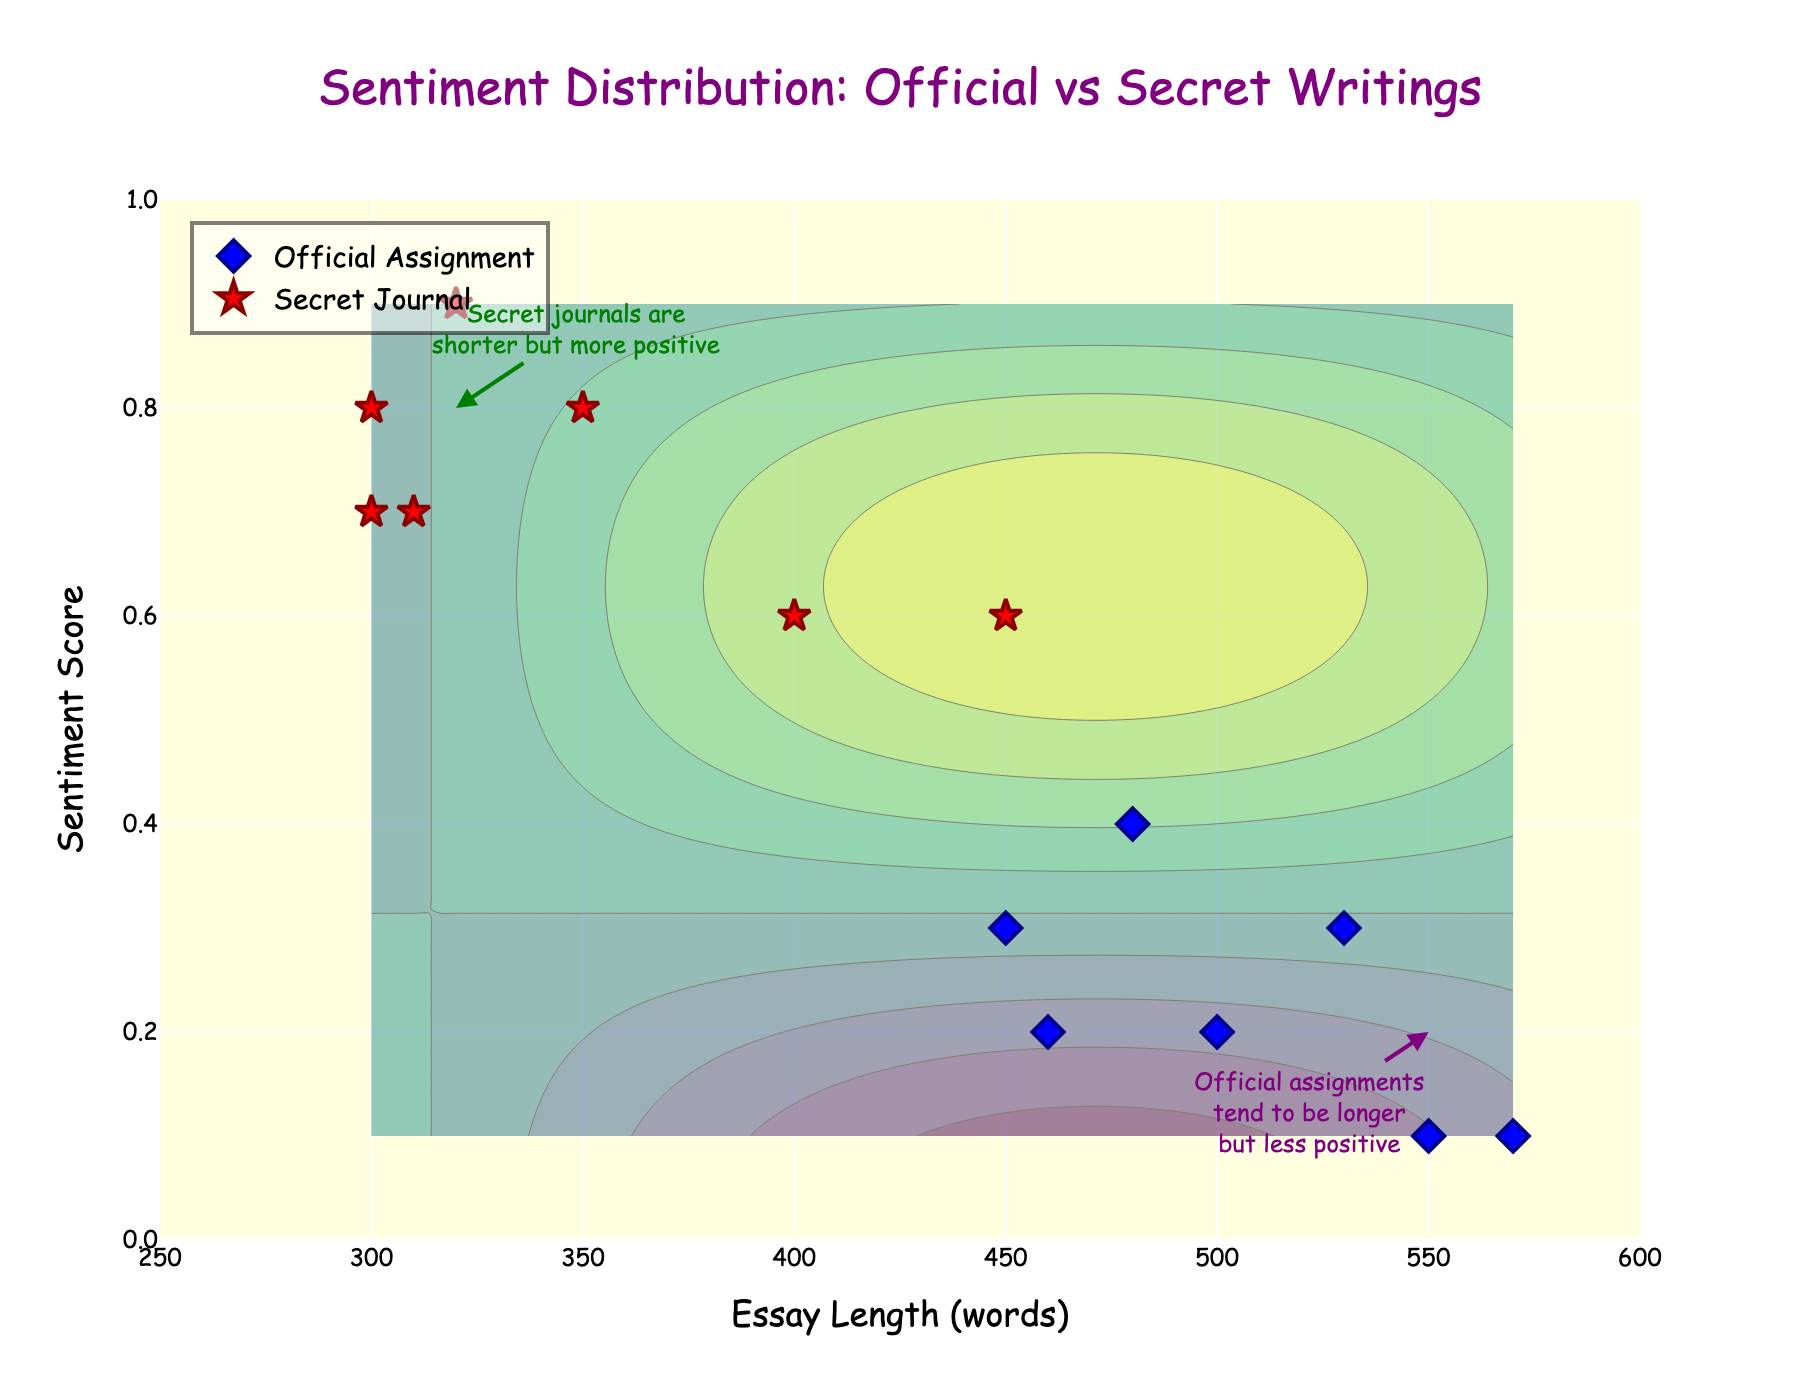What's the title of the plot? The title is located at the top of the plot and typically summarizes the main insight of the figure. In this plot, it's written in large, purple text to catch the viewer's attention.
Answer: Sentiment Distribution: Official vs Secret Writings What are the x-axis and y-axis titles? The titles for the axes are positioned along the axes themselves. The x-axis title describes what is being measured horizontally, while the y-axis title describes the vertical measurement. In this plot, they are easy to spot.
Answer: x-axis: Essay Length (words), y-axis: Sentiment Score How many data points represent Secret Journals? By looking at the markers labeled with the corresponding color for secret journals, we can count them. In this plot, red star markers represent secret journals.
Answer: 7 What's the average sentiment score for Official Assignments? Calculate the average sentiment score by first summing up all sentiment scores for official assignments (0.2 + 0.3 + 0.1 + 0.4 + 0.3 + 0.2 + 0.1), which equals 1.6. Then divide by the number of data points (7).
Answer: 0.229 In general, which type of essay tends to be longer? Compare the distributions along the x-axis for both types of essays. Official assignments are on average placed toward the right (longer lengths) while secret journals are more to the left (shorter lengths).
Answer: Official Assignments Which author has the highest sentiment score in their essay? By hovering over or reading the scatter plot markers, identify the highest point on the y-axis and check its label.
Answer: David Wilson (Secret Journal) What is the relationship between essay length and sentiment for Secret Journals? Look at the general trend of the red star markers. There appears to be a pattern in the plot indicating shorter essays generally have higher sentiment scores.
Answer: Shorter but more positive Compare the sentiment scores of Bob Smith's Official Assignment and Secret Journal. Locate Bob Smith's essays on the plot by identifying their respective markers and noting their y-axis positions. Bob's secret journal has a sentiment of 0.8, while his official assignment has 0.3.
Answer: Secret Journal is more positive Why might official assignments tend to have lower sentiment scores compared to secret journals? Consider the context and annotations. Official assignments may have more constraints and be more formal, while secret journals allow for more freedom of expression, potentially leading to higher sentiment scores.
Answer: More constraints lead to lower sentiment What does the contour represent in the background of the plot? The contour is typically used to illustrate areas of constant values or density in the background. Here, it gives a sense of the overall sentiment distribution pattern influenced by essay length.
Answer: Sentiment distribution pattern 